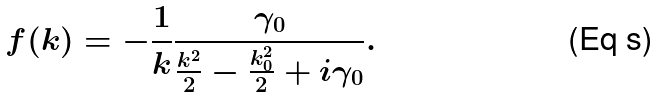Convert formula to latex. <formula><loc_0><loc_0><loc_500><loc_500>f ( k ) = - \frac { 1 } { k } \frac { \gamma _ { 0 } } { \frac { k ^ { 2 } } { 2 } - \frac { k _ { 0 } ^ { 2 } } { 2 } + i \gamma _ { 0 } } .</formula> 